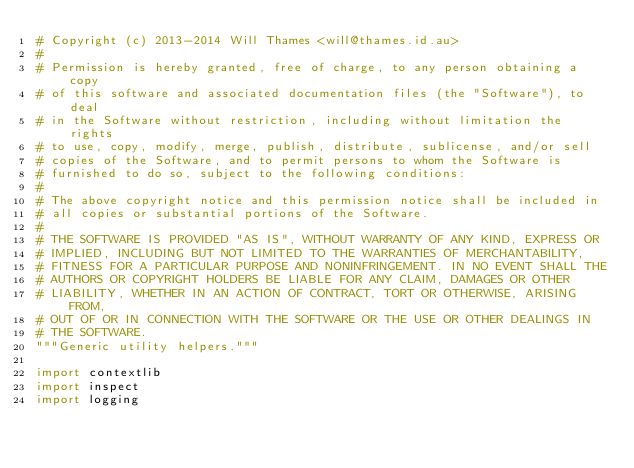<code> <loc_0><loc_0><loc_500><loc_500><_Python_># Copyright (c) 2013-2014 Will Thames <will@thames.id.au>
#
# Permission is hereby granted, free of charge, to any person obtaining a copy
# of this software and associated documentation files (the "Software"), to deal
# in the Software without restriction, including without limitation the rights
# to use, copy, modify, merge, publish, distribute, sublicense, and/or sell
# copies of the Software, and to permit persons to whom the Software is
# furnished to do so, subject to the following conditions:
#
# The above copyright notice and this permission notice shall be included in
# all copies or substantial portions of the Software.
#
# THE SOFTWARE IS PROVIDED "AS IS", WITHOUT WARRANTY OF ANY KIND, EXPRESS OR
# IMPLIED, INCLUDING BUT NOT LIMITED TO THE WARRANTIES OF MERCHANTABILITY,
# FITNESS FOR A PARTICULAR PURPOSE AND NONINFRINGEMENT. IN NO EVENT SHALL THE
# AUTHORS OR COPYRIGHT HOLDERS BE LIABLE FOR ANY CLAIM, DAMAGES OR OTHER
# LIABILITY, WHETHER IN AN ACTION OF CONTRACT, TORT OR OTHERWISE, ARISING FROM,
# OUT OF OR IN CONNECTION WITH THE SOFTWARE OR THE USE OR OTHER DEALINGS IN
# THE SOFTWARE.
"""Generic utility helpers."""

import contextlib
import inspect
import logging</code> 